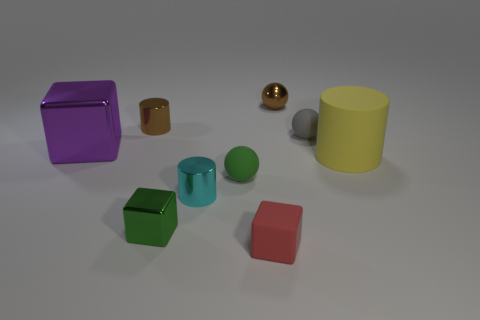Subtract all purple metallic cubes. How many cubes are left? 2 Add 1 small metal blocks. How many objects exist? 10 Subtract all brown spheres. How many spheres are left? 2 Subtract all balls. How many objects are left? 6 Subtract all yellow cubes. Subtract all green cylinders. How many cubes are left? 3 Subtract all large matte cubes. Subtract all gray things. How many objects are left? 8 Add 7 tiny red things. How many tiny red things are left? 8 Add 3 purple shiny things. How many purple shiny things exist? 4 Subtract 1 brown cylinders. How many objects are left? 8 